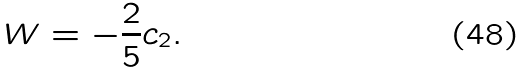<formula> <loc_0><loc_0><loc_500><loc_500>W = - \frac { 2 } { 5 } c _ { 2 } .</formula> 